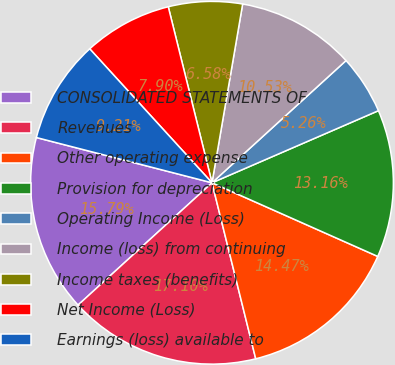<chart> <loc_0><loc_0><loc_500><loc_500><pie_chart><fcel>CONSOLIDATED STATEMENTS OF<fcel>Revenues<fcel>Other operating expense<fcel>Provision for depreciation<fcel>Operating Income (Loss)<fcel>Income (loss) from continuing<fcel>Income taxes (benefits)<fcel>Net Income (Loss)<fcel>Earnings (loss) available to<nl><fcel>15.79%<fcel>17.1%<fcel>14.47%<fcel>13.16%<fcel>5.26%<fcel>10.53%<fcel>6.58%<fcel>7.9%<fcel>9.21%<nl></chart> 